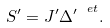<formula> <loc_0><loc_0><loc_500><loc_500>S ^ { \prime } = J ^ { \prime } { \Delta ^ { \prime } } ^ { \ e t } .</formula> 